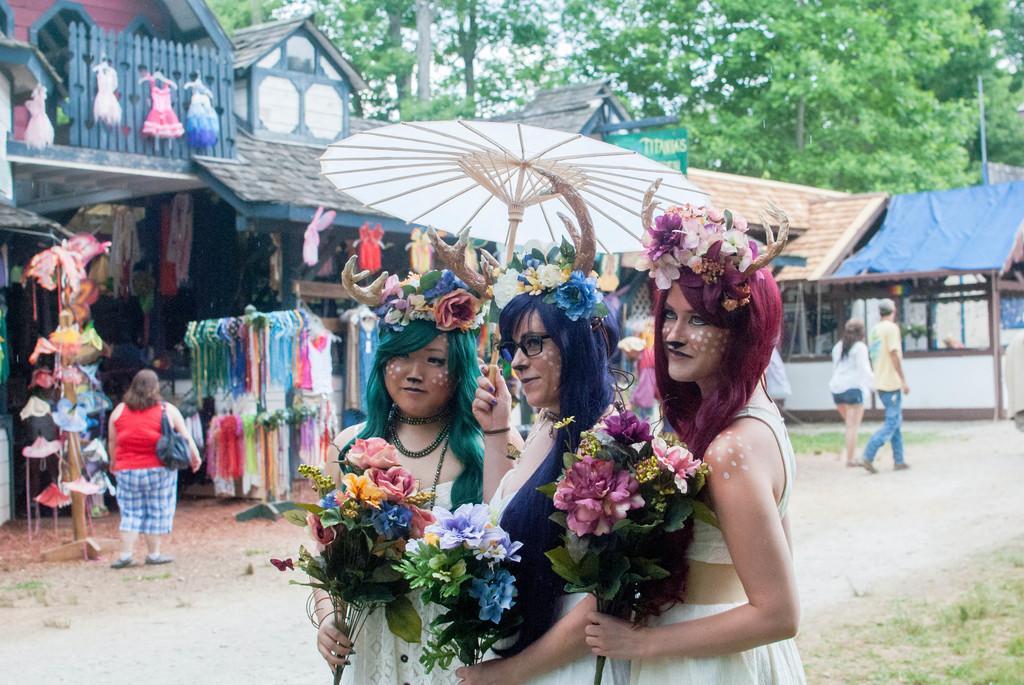How would you summarize this image in a sentence or two? In this image we can see the three girls standing in the front and holding flower bouquet. And on the left side, we can see frocks shop and a woman standing in front of shop. On the right side, we can see a man and a woman walking on the road. At back side we can see trees. In the foreground we can see grass and sand road. 